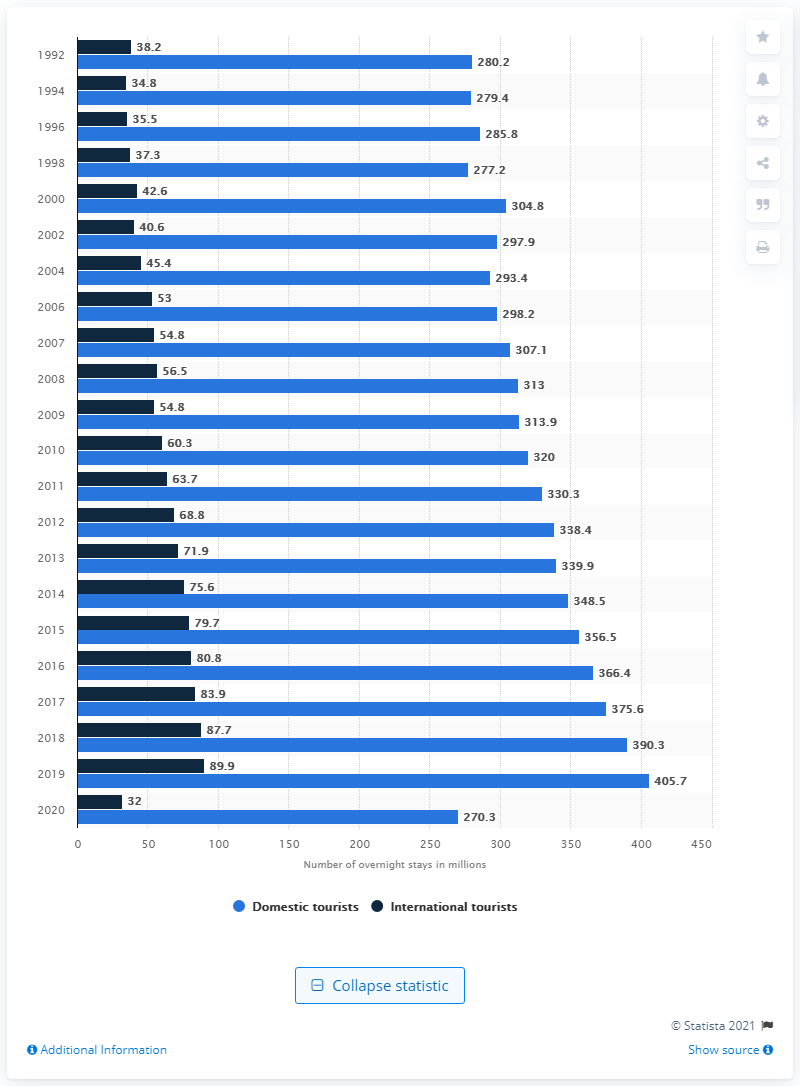Point out several critical features in this image. In 2020, there were 270.3 million overnight stays by domestic tourists in Germany. In 2020, international tourists spent a total of 32 nights in Germany. 